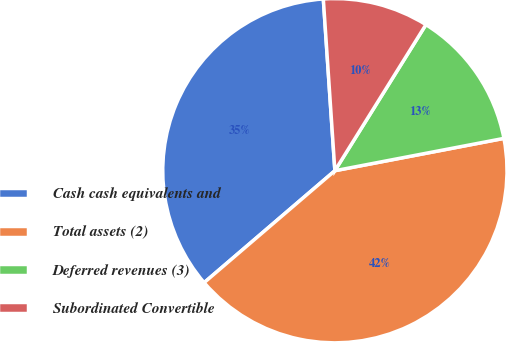Convert chart. <chart><loc_0><loc_0><loc_500><loc_500><pie_chart><fcel>Cash cash equivalents and<fcel>Total assets (2)<fcel>Deferred revenues (3)<fcel>Subordinated Convertible<nl><fcel>35.2%<fcel>41.74%<fcel>13.12%<fcel>9.94%<nl></chart> 